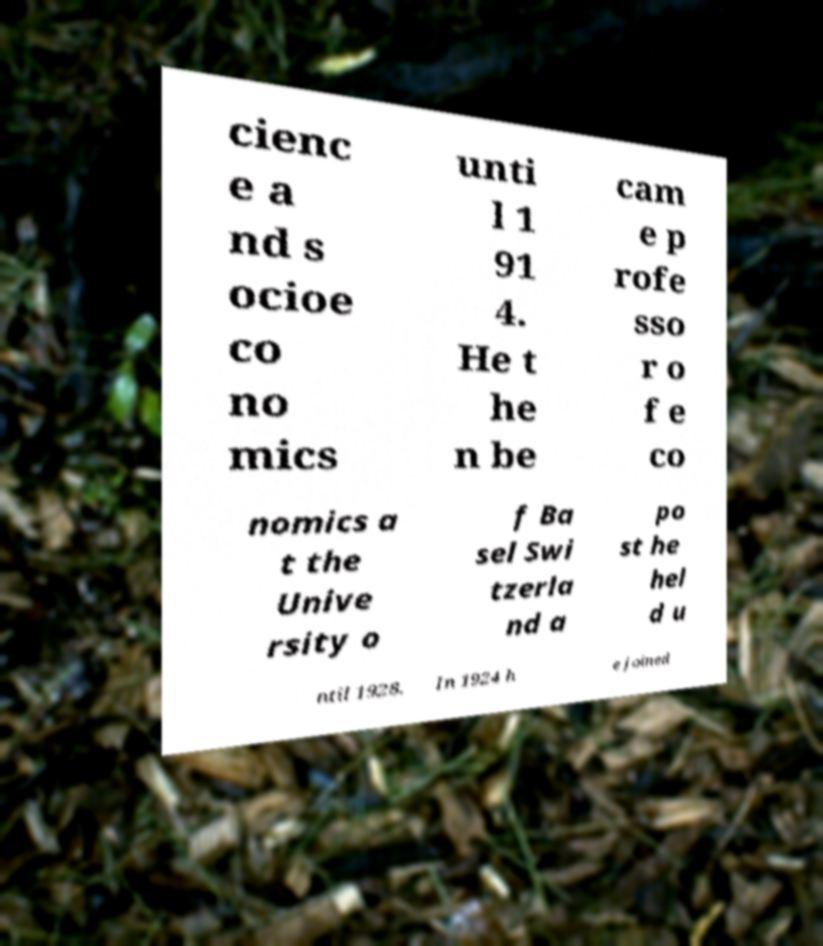Can you read and provide the text displayed in the image?This photo seems to have some interesting text. Can you extract and type it out for me? cienc e a nd s ocioe co no mics unti l 1 91 4. He t he n be cam e p rofe sso r o f e co nomics a t the Unive rsity o f Ba sel Swi tzerla nd a po st he hel d u ntil 1928. In 1924 h e joined 